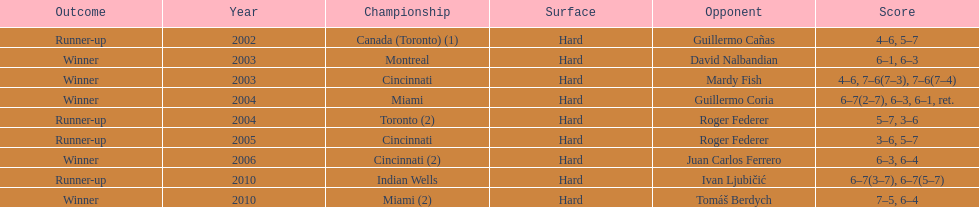On how many occasions were roddick's competitors not from the usa? 8. 